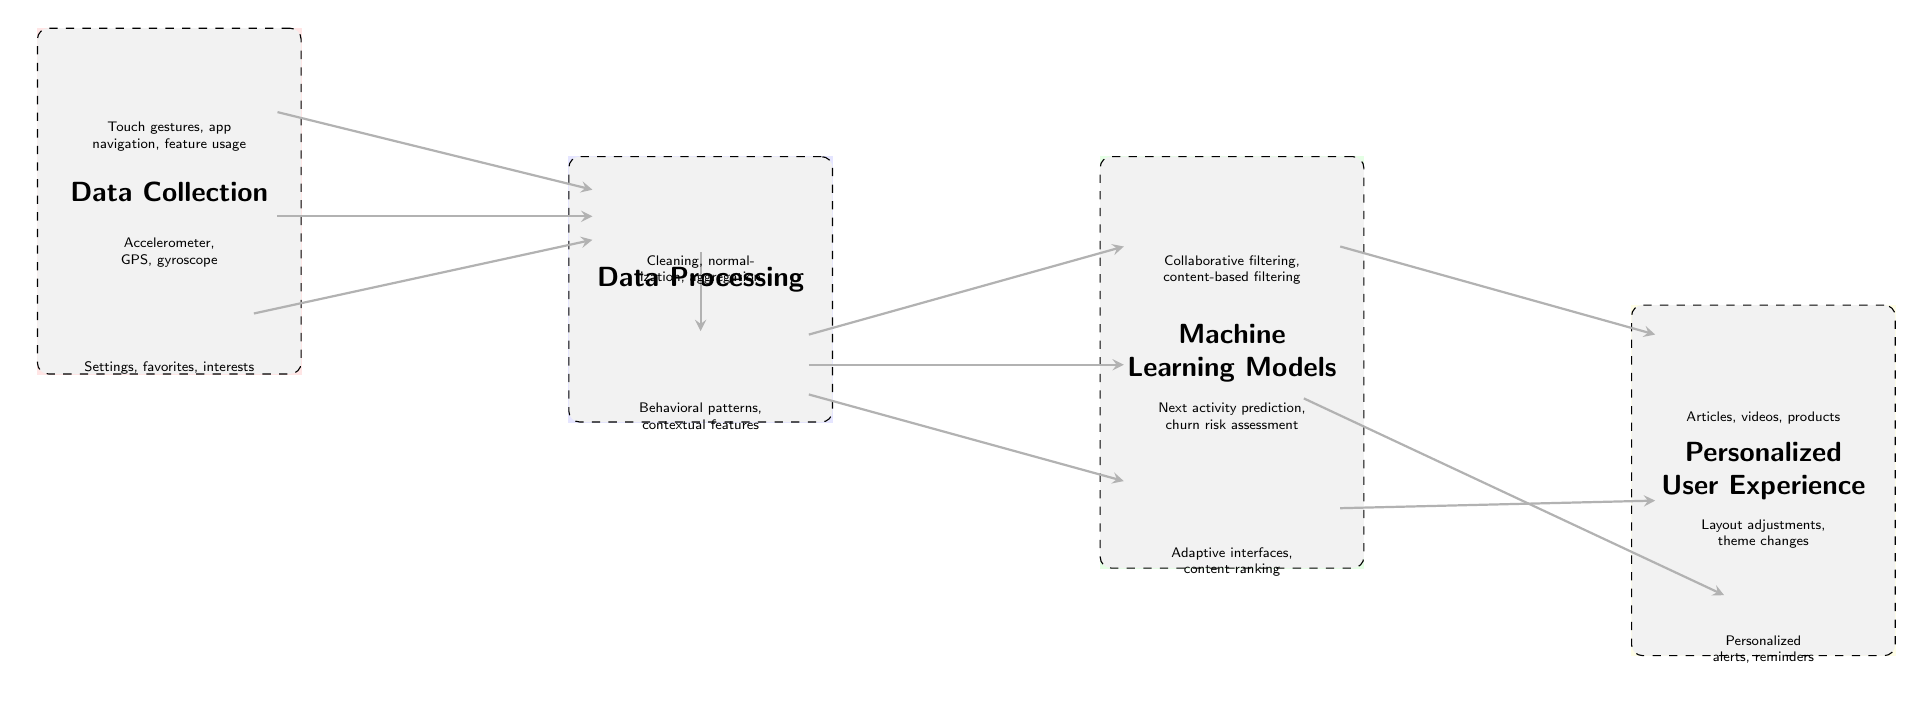What are the three types of user data collected? The diagram lists three types of user data: User Interaction Events, Device Sensors, and User Preferences. These nodes are located in the Data Collection layer.
Answer: User Interaction Events, Device Sensors, User Preferences How many nodes are in the Data Processing layer? The Data Processing layer contains two nodes: Data Preprocessing and Feature Extraction, which are clearly displayed in that layer.
Answer: 2 What is the output of the Recommendation Engine? The Recommendation Engine produces Content Suggestions. This connection is illustrated as an arrow from the Recommendation Engine node to the Content Suggestions node in the Personalized User Experience layer.
Answer: Content Suggestions Which layer does the Personalization Model belong to? The Personalization Model is one of the three nodes located in the Machine Learning Models layer, as shown in the diagram.
Answer: Machine Learning Models What types of features are extracted in the Data Processing layer? In the Data Processing layer, Feature Extraction focuses on behavioral patterns and contextual features, specifically stated in the description below the Feature Extraction node.
Answer: Behavioral patterns, contextual features How do Interface Tweaks get generated? Interface Tweaks are generated as a result of processing by the Personalization Model. The flow can be traced from Feature Extraction to Personalization Model and subsequently to Interface Tweaks.
Answer: Personalization Model What does the Data Preprocessing node handle? The Data Preprocessing node is responsible for Cleaning, normalization, and aggregation of data, as indicated in the description next to that node.
Answer: Cleaning, normalization, aggregation Which machine learning model predicts churn risk? The Behavior Prediction Model is the one that predicts churn risk, as detailed in its description beneath that node in the Machine Learning Models layer.
Answer: Behavior Prediction Model What do Notifications represent in the personalized experience? Notifications are personalized alerts and reminders, which are shown in their respective node in the Personalized User Experience layer with a clear description provided below.
Answer: Personalized alerts, reminders 